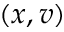Convert formula to latex. <formula><loc_0><loc_0><loc_500><loc_500>( x , v )</formula> 